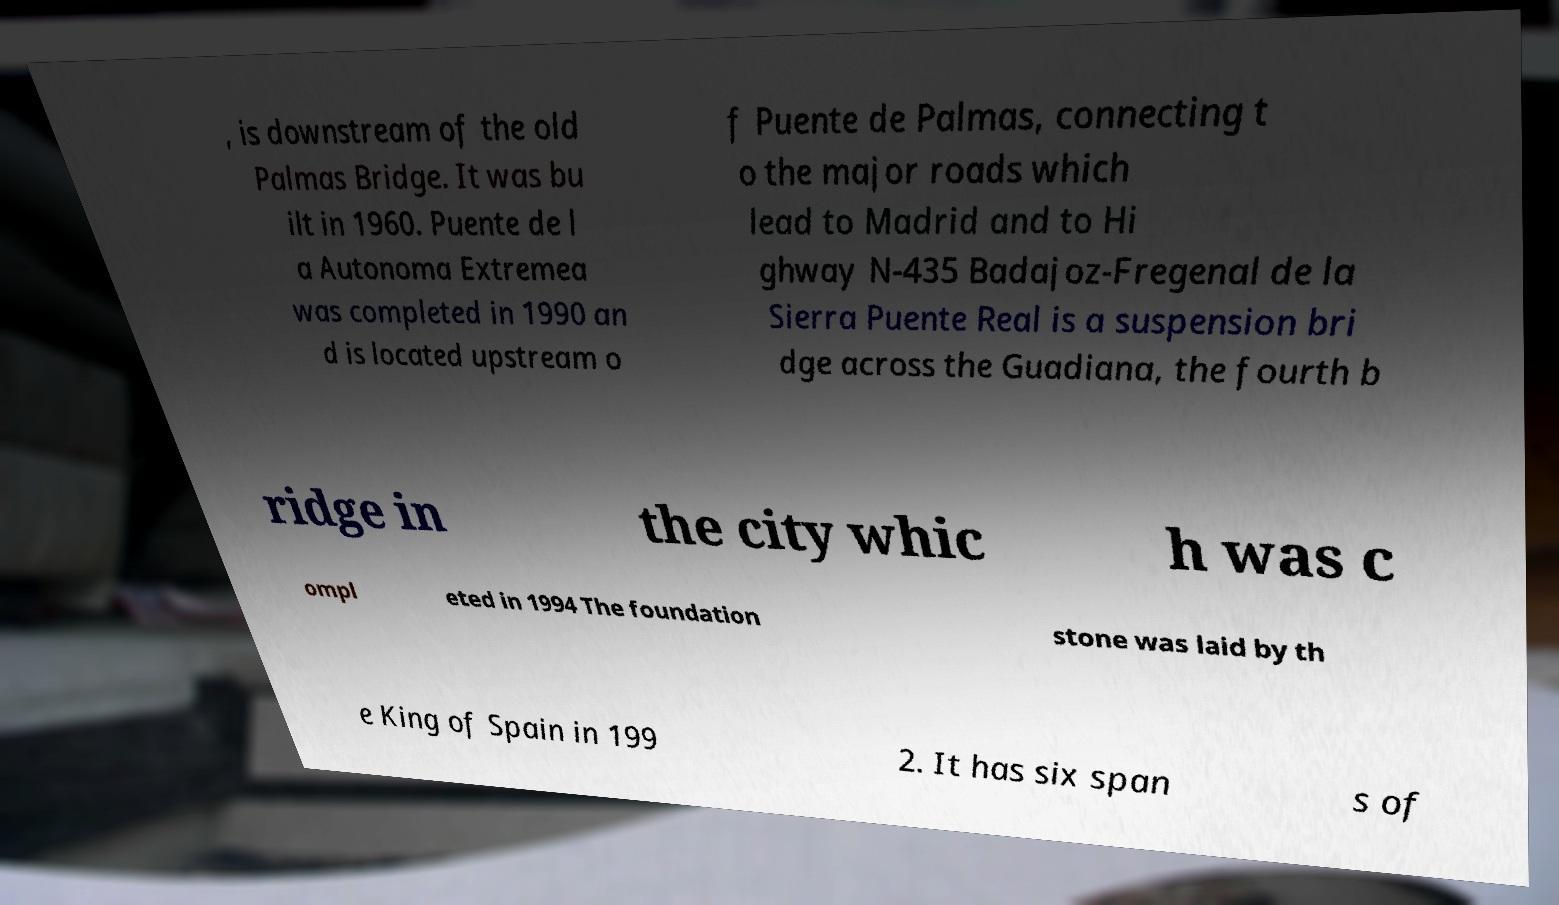For documentation purposes, I need the text within this image transcribed. Could you provide that? , is downstream of the old Palmas Bridge. It was bu ilt in 1960. Puente de l a Autonoma Extremea was completed in 1990 an d is located upstream o f Puente de Palmas, connecting t o the major roads which lead to Madrid and to Hi ghway N-435 Badajoz-Fregenal de la Sierra Puente Real is a suspension bri dge across the Guadiana, the fourth b ridge in the city whic h was c ompl eted in 1994 The foundation stone was laid by th e King of Spain in 199 2. It has six span s of 